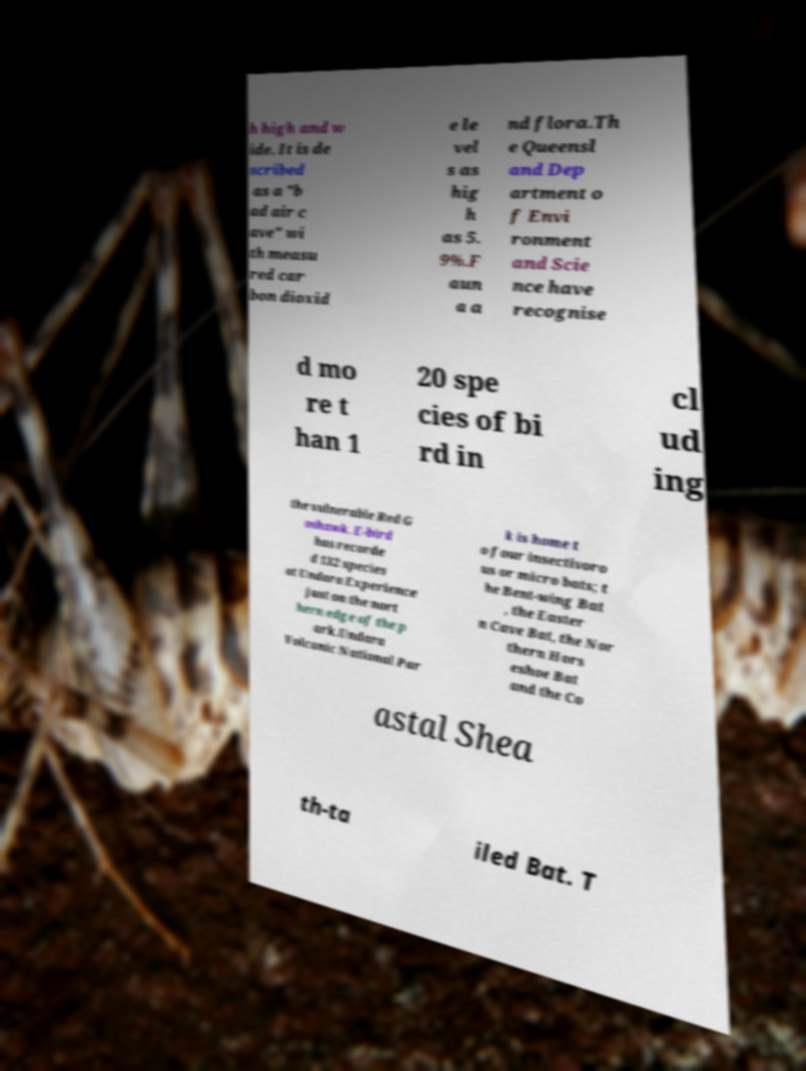Could you assist in decoding the text presented in this image and type it out clearly? h high and w ide. It is de scribed as a "b ad air c ave" wi th measu red car bon dioxid e le vel s as hig h as 5. 9%.F aun a a nd flora.Th e Queensl and Dep artment o f Envi ronment and Scie nce have recognise d mo re t han 1 20 spe cies of bi rd in cl ud ing the vulnerable Red G oshawk. E-bird has recorde d 132 species at Undara Experience just on the nort hern edge of the p ark.Undara Volcanic National Par k is home t o four insectivoro us or micro bats; t he Bent-wing Bat , the Easter n Cave Bat, the Nor thern Hors eshoe Bat and the Co astal Shea th-ta iled Bat. T 